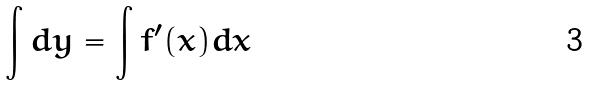<formula> <loc_0><loc_0><loc_500><loc_500>\int d y = \int f ^ { \prime } ( x ) d x</formula> 